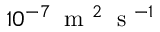<formula> <loc_0><loc_0><loc_500><loc_500>1 0 ^ { - 7 } \, m ^ { 2 } \, s ^ { - 1 }</formula> 